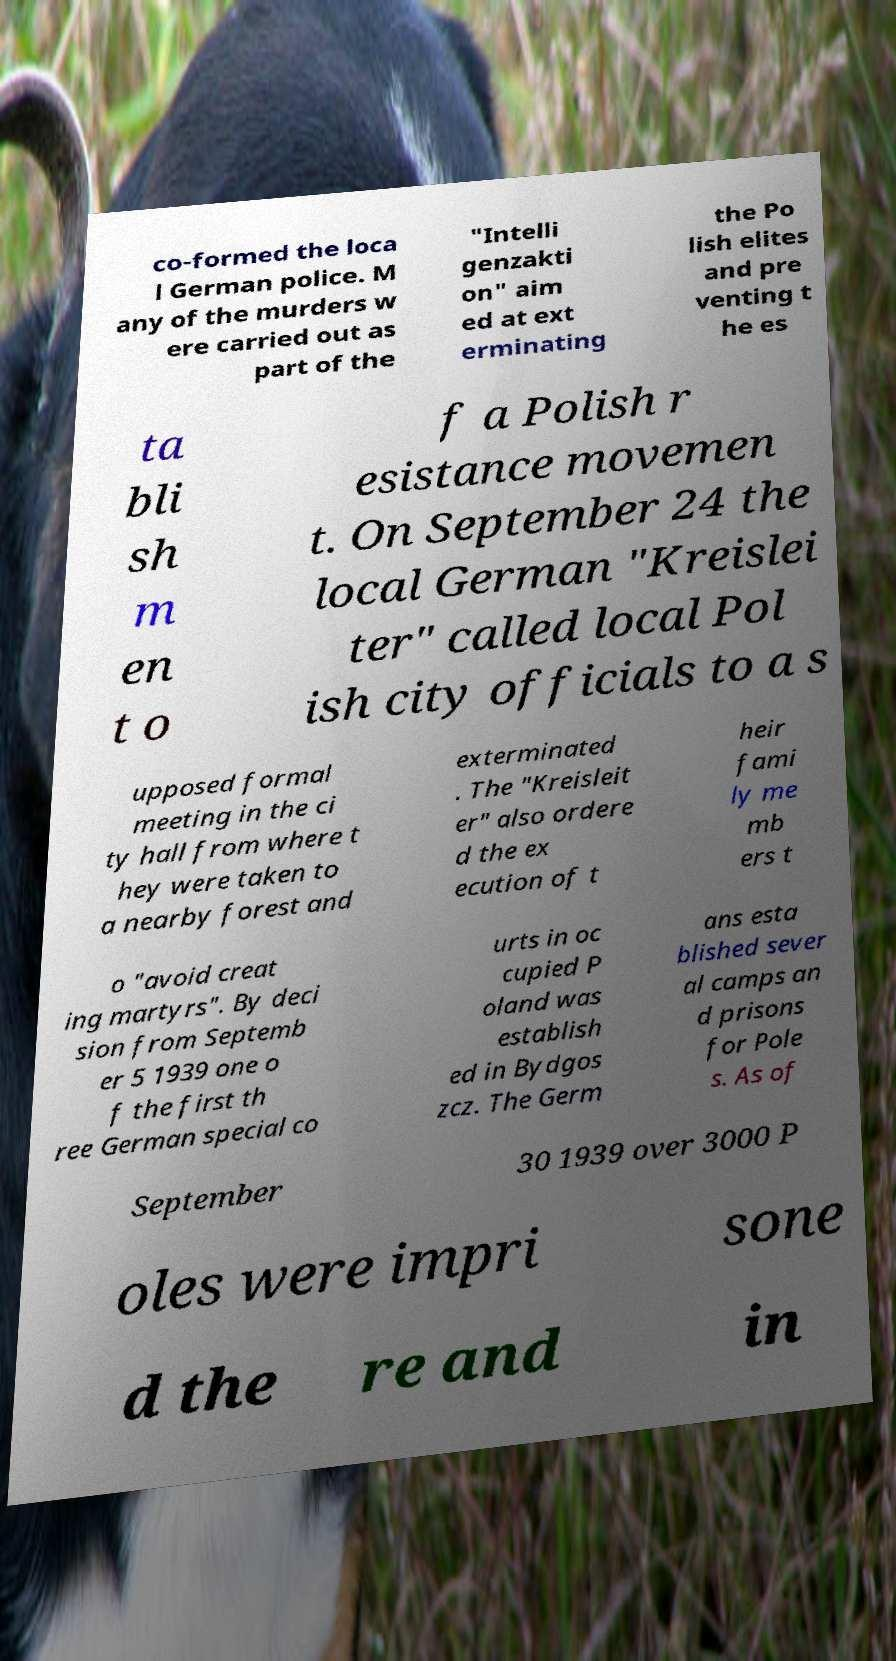For documentation purposes, I need the text within this image transcribed. Could you provide that? co-formed the loca l German police. M any of the murders w ere carried out as part of the "Intelli genzakti on" aim ed at ext erminating the Po lish elites and pre venting t he es ta bli sh m en t o f a Polish r esistance movemen t. On September 24 the local German "Kreislei ter" called local Pol ish city officials to a s upposed formal meeting in the ci ty hall from where t hey were taken to a nearby forest and exterminated . The "Kreisleit er" also ordere d the ex ecution of t heir fami ly me mb ers t o "avoid creat ing martyrs". By deci sion from Septemb er 5 1939 one o f the first th ree German special co urts in oc cupied P oland was establish ed in Bydgos zcz. The Germ ans esta blished sever al camps an d prisons for Pole s. As of September 30 1939 over 3000 P oles were impri sone d the re and in 